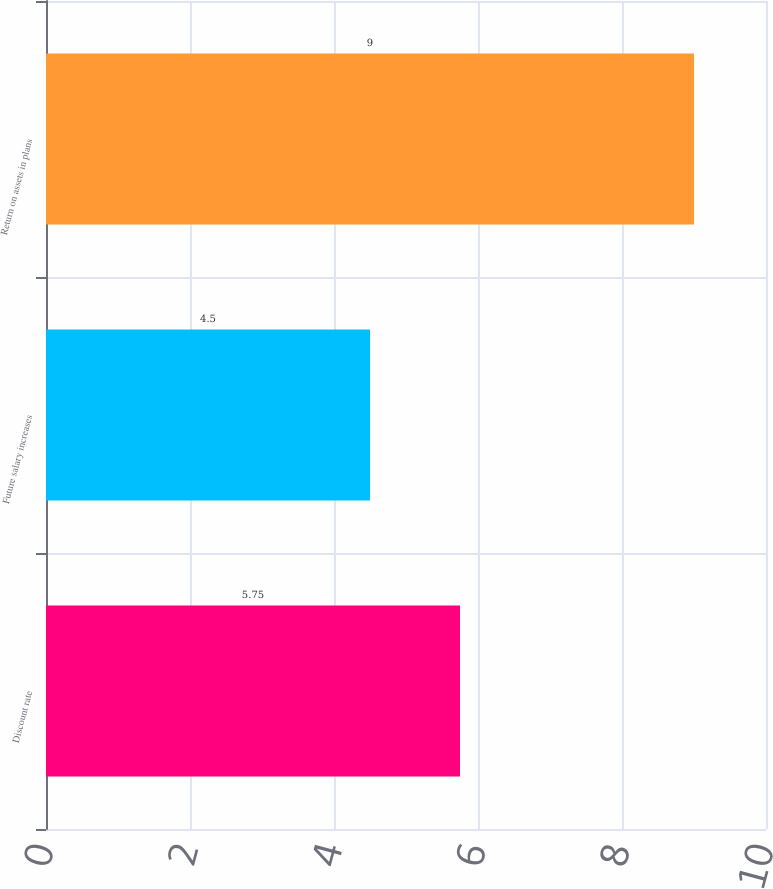Convert chart. <chart><loc_0><loc_0><loc_500><loc_500><bar_chart><fcel>Discount rate<fcel>Future salary increases<fcel>Return on assets in plans<nl><fcel>5.75<fcel>4.5<fcel>9<nl></chart> 